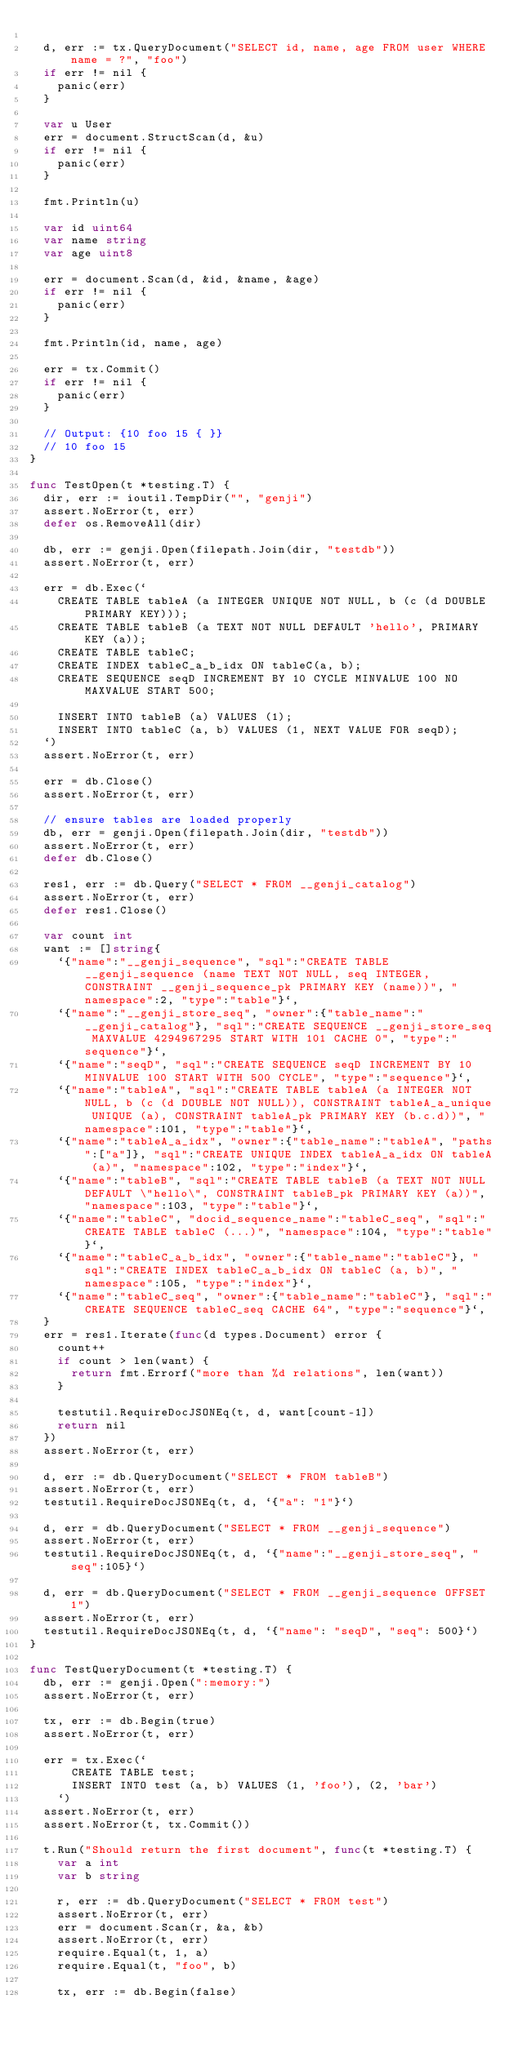Convert code to text. <code><loc_0><loc_0><loc_500><loc_500><_Go_>
	d, err := tx.QueryDocument("SELECT id, name, age FROM user WHERE name = ?", "foo")
	if err != nil {
		panic(err)
	}

	var u User
	err = document.StructScan(d, &u)
	if err != nil {
		panic(err)
	}

	fmt.Println(u)

	var id uint64
	var name string
	var age uint8

	err = document.Scan(d, &id, &name, &age)
	if err != nil {
		panic(err)
	}

	fmt.Println(id, name, age)

	err = tx.Commit()
	if err != nil {
		panic(err)
	}

	// Output: {10 foo 15 { }}
	// 10 foo 15
}

func TestOpen(t *testing.T) {
	dir, err := ioutil.TempDir("", "genji")
	assert.NoError(t, err)
	defer os.RemoveAll(dir)

	db, err := genji.Open(filepath.Join(dir, "testdb"))
	assert.NoError(t, err)

	err = db.Exec(`
		CREATE TABLE tableA (a INTEGER UNIQUE NOT NULL, b (c (d DOUBLE PRIMARY KEY)));
		CREATE TABLE tableB (a TEXT NOT NULL DEFAULT 'hello', PRIMARY KEY (a));
		CREATE TABLE tableC;
		CREATE INDEX tableC_a_b_idx ON tableC(a, b);
		CREATE SEQUENCE seqD INCREMENT BY 10 CYCLE MINVALUE 100 NO MAXVALUE START 500;

		INSERT INTO tableB (a) VALUES (1);
		INSERT INTO tableC (a, b) VALUES (1, NEXT VALUE FOR seqD);
	`)
	assert.NoError(t, err)

	err = db.Close()
	assert.NoError(t, err)

	// ensure tables are loaded properly
	db, err = genji.Open(filepath.Join(dir, "testdb"))
	assert.NoError(t, err)
	defer db.Close()

	res1, err := db.Query("SELECT * FROM __genji_catalog")
	assert.NoError(t, err)
	defer res1.Close()

	var count int
	want := []string{
		`{"name":"__genji_sequence", "sql":"CREATE TABLE __genji_sequence (name TEXT NOT NULL, seq INTEGER, CONSTRAINT __genji_sequence_pk PRIMARY KEY (name))", "namespace":2, "type":"table"}`,
		`{"name":"__genji_store_seq", "owner":{"table_name":"__genji_catalog"}, "sql":"CREATE SEQUENCE __genji_store_seq MAXVALUE 4294967295 START WITH 101 CACHE 0", "type":"sequence"}`,
		`{"name":"seqD", "sql":"CREATE SEQUENCE seqD INCREMENT BY 10 MINVALUE 100 START WITH 500 CYCLE", "type":"sequence"}`,
		`{"name":"tableA", "sql":"CREATE TABLE tableA (a INTEGER NOT NULL, b (c (d DOUBLE NOT NULL)), CONSTRAINT tableA_a_unique UNIQUE (a), CONSTRAINT tableA_pk PRIMARY KEY (b.c.d))", "namespace":101, "type":"table"}`,
		`{"name":"tableA_a_idx", "owner":{"table_name":"tableA", "paths":["a"]}, "sql":"CREATE UNIQUE INDEX tableA_a_idx ON tableA (a)", "namespace":102, "type":"index"}`,
		`{"name":"tableB", "sql":"CREATE TABLE tableB (a TEXT NOT NULL DEFAULT \"hello\", CONSTRAINT tableB_pk PRIMARY KEY (a))", "namespace":103, "type":"table"}`,
		`{"name":"tableC", "docid_sequence_name":"tableC_seq", "sql":"CREATE TABLE tableC (...)", "namespace":104, "type":"table"}`,
		`{"name":"tableC_a_b_idx", "owner":{"table_name":"tableC"}, "sql":"CREATE INDEX tableC_a_b_idx ON tableC (a, b)", "namespace":105, "type":"index"}`,
		`{"name":"tableC_seq", "owner":{"table_name":"tableC"}, "sql":"CREATE SEQUENCE tableC_seq CACHE 64", "type":"sequence"}`,
	}
	err = res1.Iterate(func(d types.Document) error {
		count++
		if count > len(want) {
			return fmt.Errorf("more than %d relations", len(want))
		}

		testutil.RequireDocJSONEq(t, d, want[count-1])
		return nil
	})
	assert.NoError(t, err)

	d, err := db.QueryDocument("SELECT * FROM tableB")
	assert.NoError(t, err)
	testutil.RequireDocJSONEq(t, d, `{"a": "1"}`)

	d, err = db.QueryDocument("SELECT * FROM __genji_sequence")
	assert.NoError(t, err)
	testutil.RequireDocJSONEq(t, d, `{"name":"__genji_store_seq", "seq":105}`)

	d, err = db.QueryDocument("SELECT * FROM __genji_sequence OFFSET 1")
	assert.NoError(t, err)
	testutil.RequireDocJSONEq(t, d, `{"name": "seqD", "seq": 500}`)
}

func TestQueryDocument(t *testing.T) {
	db, err := genji.Open(":memory:")
	assert.NoError(t, err)

	tx, err := db.Begin(true)
	assert.NoError(t, err)

	err = tx.Exec(`
			CREATE TABLE test;
			INSERT INTO test (a, b) VALUES (1, 'foo'), (2, 'bar')
		`)
	assert.NoError(t, err)
	assert.NoError(t, tx.Commit())

	t.Run("Should return the first document", func(t *testing.T) {
		var a int
		var b string

		r, err := db.QueryDocument("SELECT * FROM test")
		assert.NoError(t, err)
		err = document.Scan(r, &a, &b)
		assert.NoError(t, err)
		require.Equal(t, 1, a)
		require.Equal(t, "foo", b)

		tx, err := db.Begin(false)</code> 